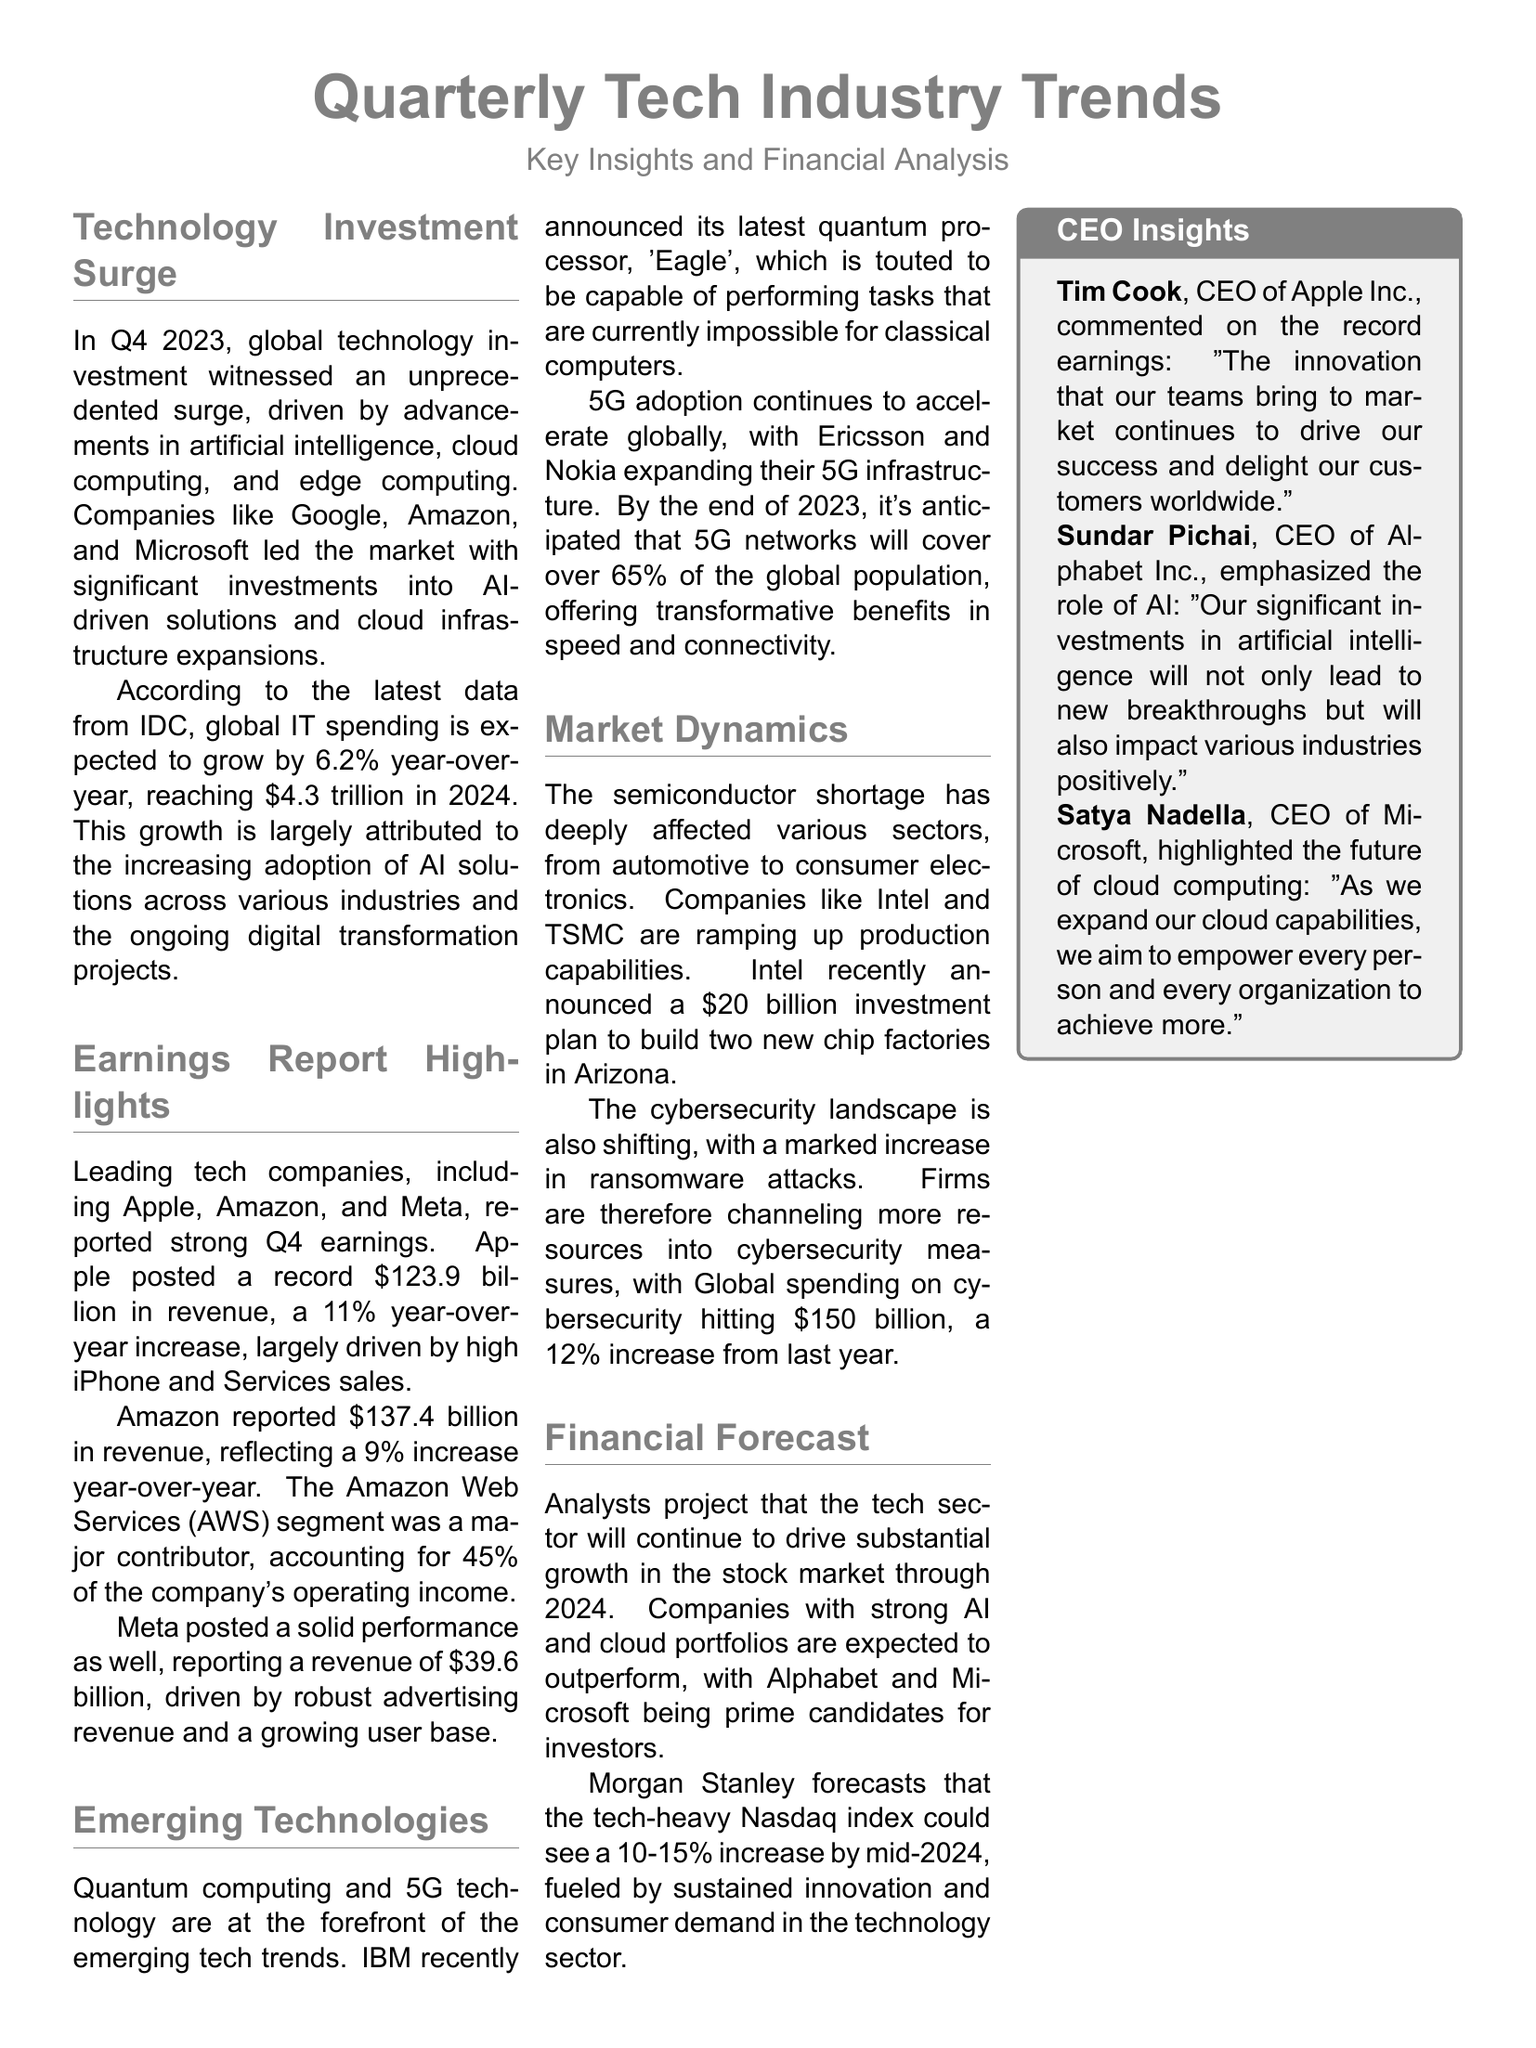What was the global technology investment surge percentage in Q4 2023? The document states that global technology investment witnessed an unprecedented surge but doesn't specify a percentage for Q4 2023.
Answer: Not specified Which company had the highest revenue in Q4? According to the earnings report highlights, Apple had the highest revenue at $123.9 billion.
Answer: $123.9 billion What is the projected growth rate of global IT spending in 2024? The document indicates that global IT spending is expected to grow by 6.2% year-over-year in 2024.
Answer: 6.2% What technology did IBM announce? The document mentions that IBM announced its latest quantum processor, 'Eagle'.
Answer: Eagle How much did Intel invest for new chip factories? Intel recently announced a $20 billion investment plan to build two new chip factories in Arizona.
Answer: $20 billion What percentage of Amazon's revenue came from AWS? The document states that the AWS segment accounted for 45% of Amazon's operating income.
Answer: 45% What was the total global spending on cybersecurity? The document indicates that global spending on cybersecurity hit $150 billion.
Answer: $150 billion By what percentage could the Nasdaq index increase by mid-2024? The document predicts that the Nasdaq index could see a 10-15% increase by mid-2024.
Answer: 10-15% Who commented on Apple's record earnings? The document lists Tim Cook, CEO of Apple Inc., as the person who commented on this.
Answer: Tim Cook 